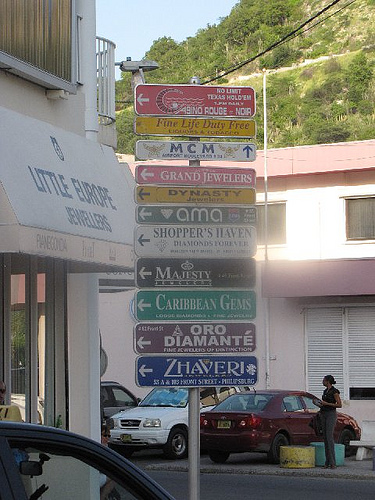Extract all visible text content from this image. EUROPE GRAND ZHAVERI DIAMANTE ORO GEMS CARIBBEAN MAJESTY HAVEN SHOPPER'S ama DYNASTY JEWELERS MCM Free Life NOOR 